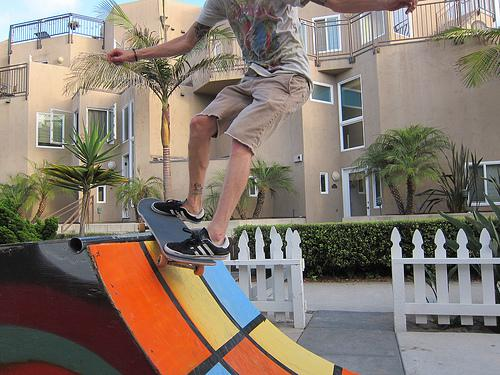Question: who is wearing shorts?
Choices:
A. Biker.
B. Skateboarder.
C. Girl.
D. Runner.
Answer with the letter. Answer: B Question: what color is a fence?
Choices:
A. White.
B. Silver.
C. Black.
D. Brown.
Answer with the letter. Answer: A Question: where are wheels?
Choices:
A. On a car.
B. On a bus.
C. On a skateboard.
D. On a bicycle.
Answer with the letter. Answer: C Question: when was the picture taken?
Choices:
A. Afternoon.
B. Daytime.
C. Dusk.
D. Morning.
Answer with the letter. Answer: B Question: where are windows?
Choices:
A. On a car.
B. On a train.
C. On a building.
D. On a bus.
Answer with the letter. Answer: C 